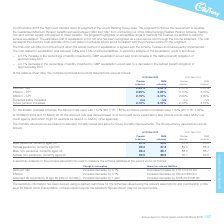According to Premier Foods Plc's financial document, What was the discount rate used for smaller overseas schemes in 2018/19? According to the financial document, 1.50%. The relevant text states: "maller overseas schemes the discount rate used was 1.50% (2017/18: 1.80%) and future pension increases were 1.30% (2017/18: 1.45%)...." Also, What was the discount rate at 30 March 2019 based on? a bond yield curve expanded to also include bonds rated AA by one credit agency (and which might for example be rated A or AAA by other agencies).. The document states: "March 2018, the discount rate was derived based on a bond yield curve expanded to also include bonds rated AA by one credit agency (and which might fo..." Also, What was the discount rate at 30 March 2019 for premier schemes? According to the financial document, 2.45 (percentage). The relevant text states: "Premier schemes RHM schemes Discount rate 2.45% 2.45% 2.70% 2.70% Inflation – RPI 3.25% 3.25% 3.15% 3.15% Inflation – CPI 2.15% 2.15% 2.05% 2.05%..." Also, can you calculate: What is the change in the premier schemes discount rate from 2018 to 2019? Based on the calculation: 2.45% - 2.70%, the result is -0.25 (percentage). This is based on the information: "Premier schemes RHM schemes Discount rate 2.45% 2.45% 2.70% 2.70% Inflation – RPI 3.25% 3.25% 3.15% 3.15% Inflation – CPI 2.15% 2.15% 2.05% 2.05% ier schemes RHM schemes Discount rate 2.45% 2.45% 2.70..." The key data points involved are: 2.45, 2.70. Also, can you calculate: What is the average inflation RPI for premier schemes? To answer this question, I need to perform calculations using the financial data. The calculation is: (3.25% + 3.15%) / 2, which equals 3.2 (percentage). This is based on the information: "45% 2.45% 2.70% 2.70% Inflation – RPI 3.25% 3.25% 3.15% 3.15% Inflation – CPI 2.15% 2.15% 2.05% 2.05% Expected salary increases n/a n/a n/a n/a Future pen ount rate 2.45% 2.45% 2.70% 2.70% Inflation –..." The key data points involved are: 3.15, 3.25. Also, can you calculate: What is the change in the inflation - CPI for RHm schemes from 2018 to 2019? Based on the calculation: 2.15% - 2.05%, the result is 0.1 (percentage). This is based on the information: "25% 3.25% 3.15% 3.15% Inflation – CPI 2.15% 2.15% 2.05% 2.05% Expected salary increases n/a n/a n/a n/a Future pension increases 2.10% 2.10% 2.10% 2.10% ion – RPI 3.25% 3.25% 3.15% 3.15% Inflation – C..." The key data points involved are: 2.05, 2.15. 